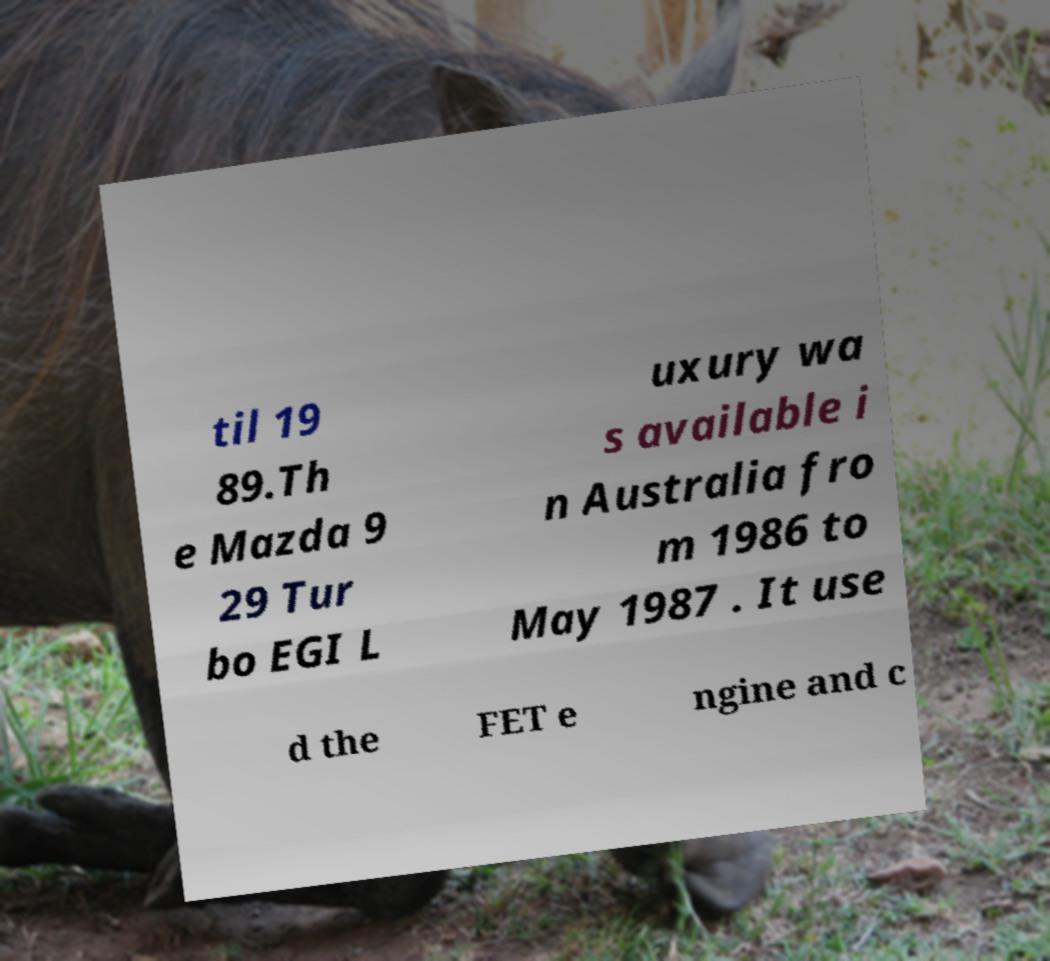There's text embedded in this image that I need extracted. Can you transcribe it verbatim? til 19 89.Th e Mazda 9 29 Tur bo EGI L uxury wa s available i n Australia fro m 1986 to May 1987 . It use d the FET e ngine and c 